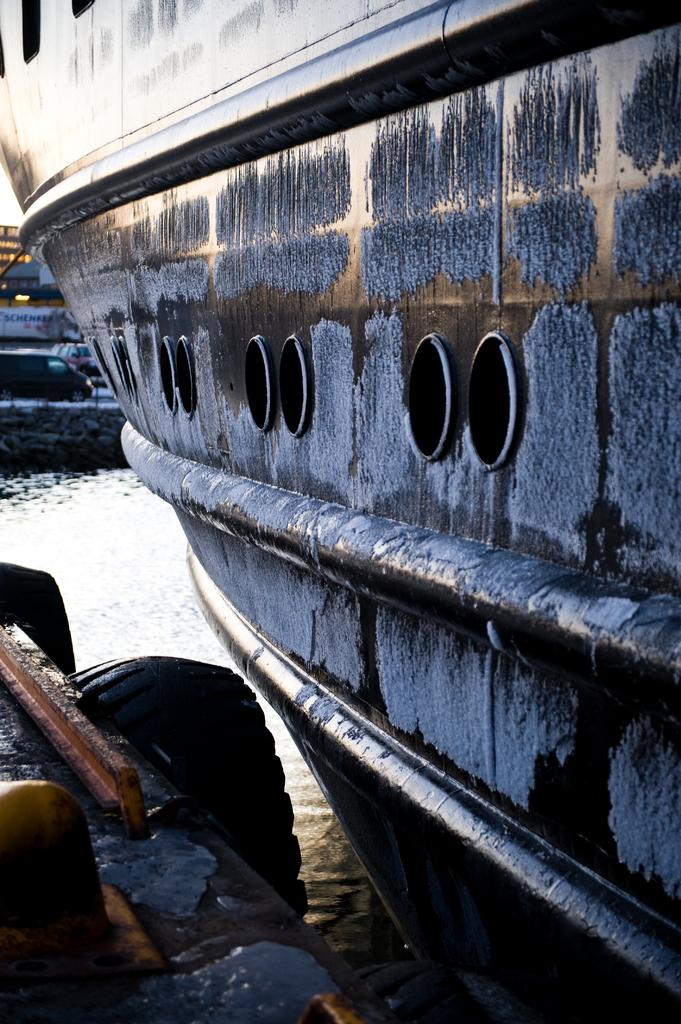What type of vehicle is located on the right side of the image? There is a ship on the right side of the image. What other mode of transportation can be seen in the image? There is a car visible in the background of the image. What type of lace is being used to tie the ship to the car in the image? There is no lace present in the image, nor is the ship tied to the car. 